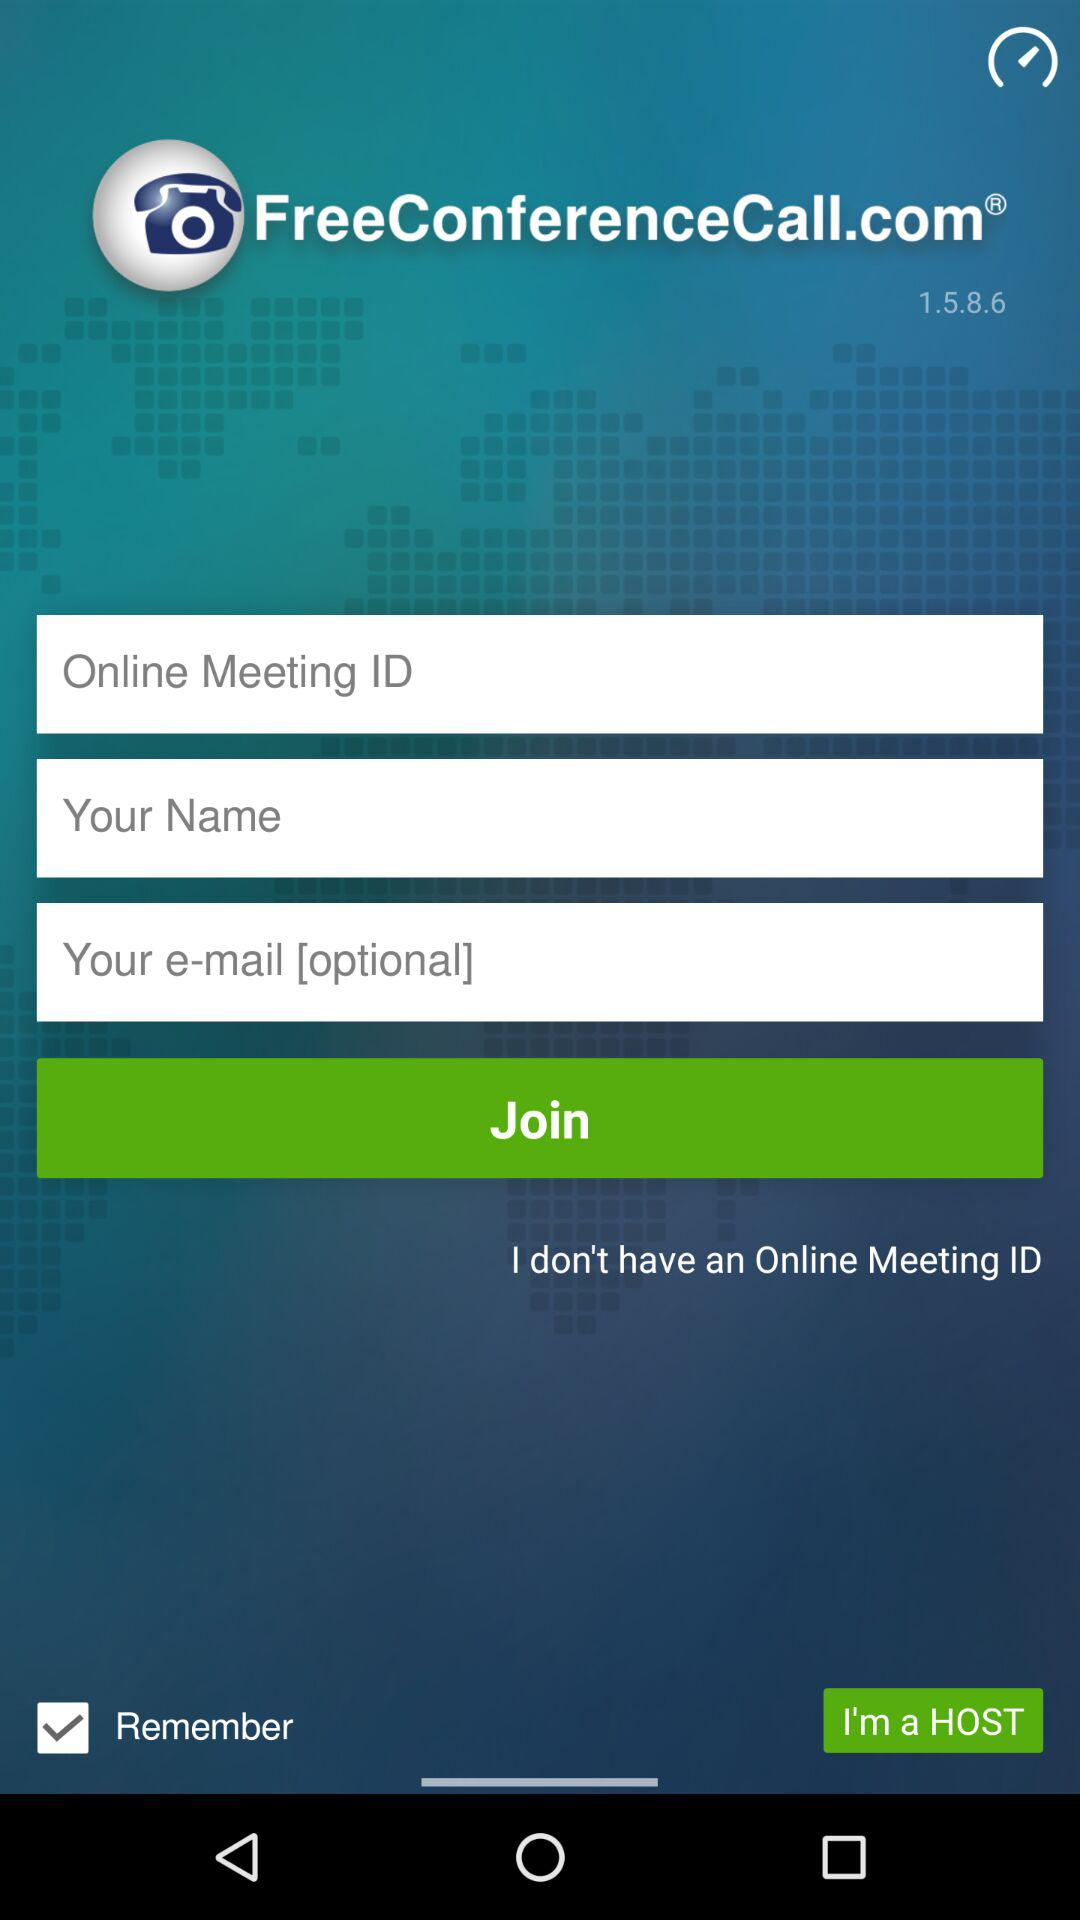What is the app title? The app title is "FreeConferenceCall.com". 